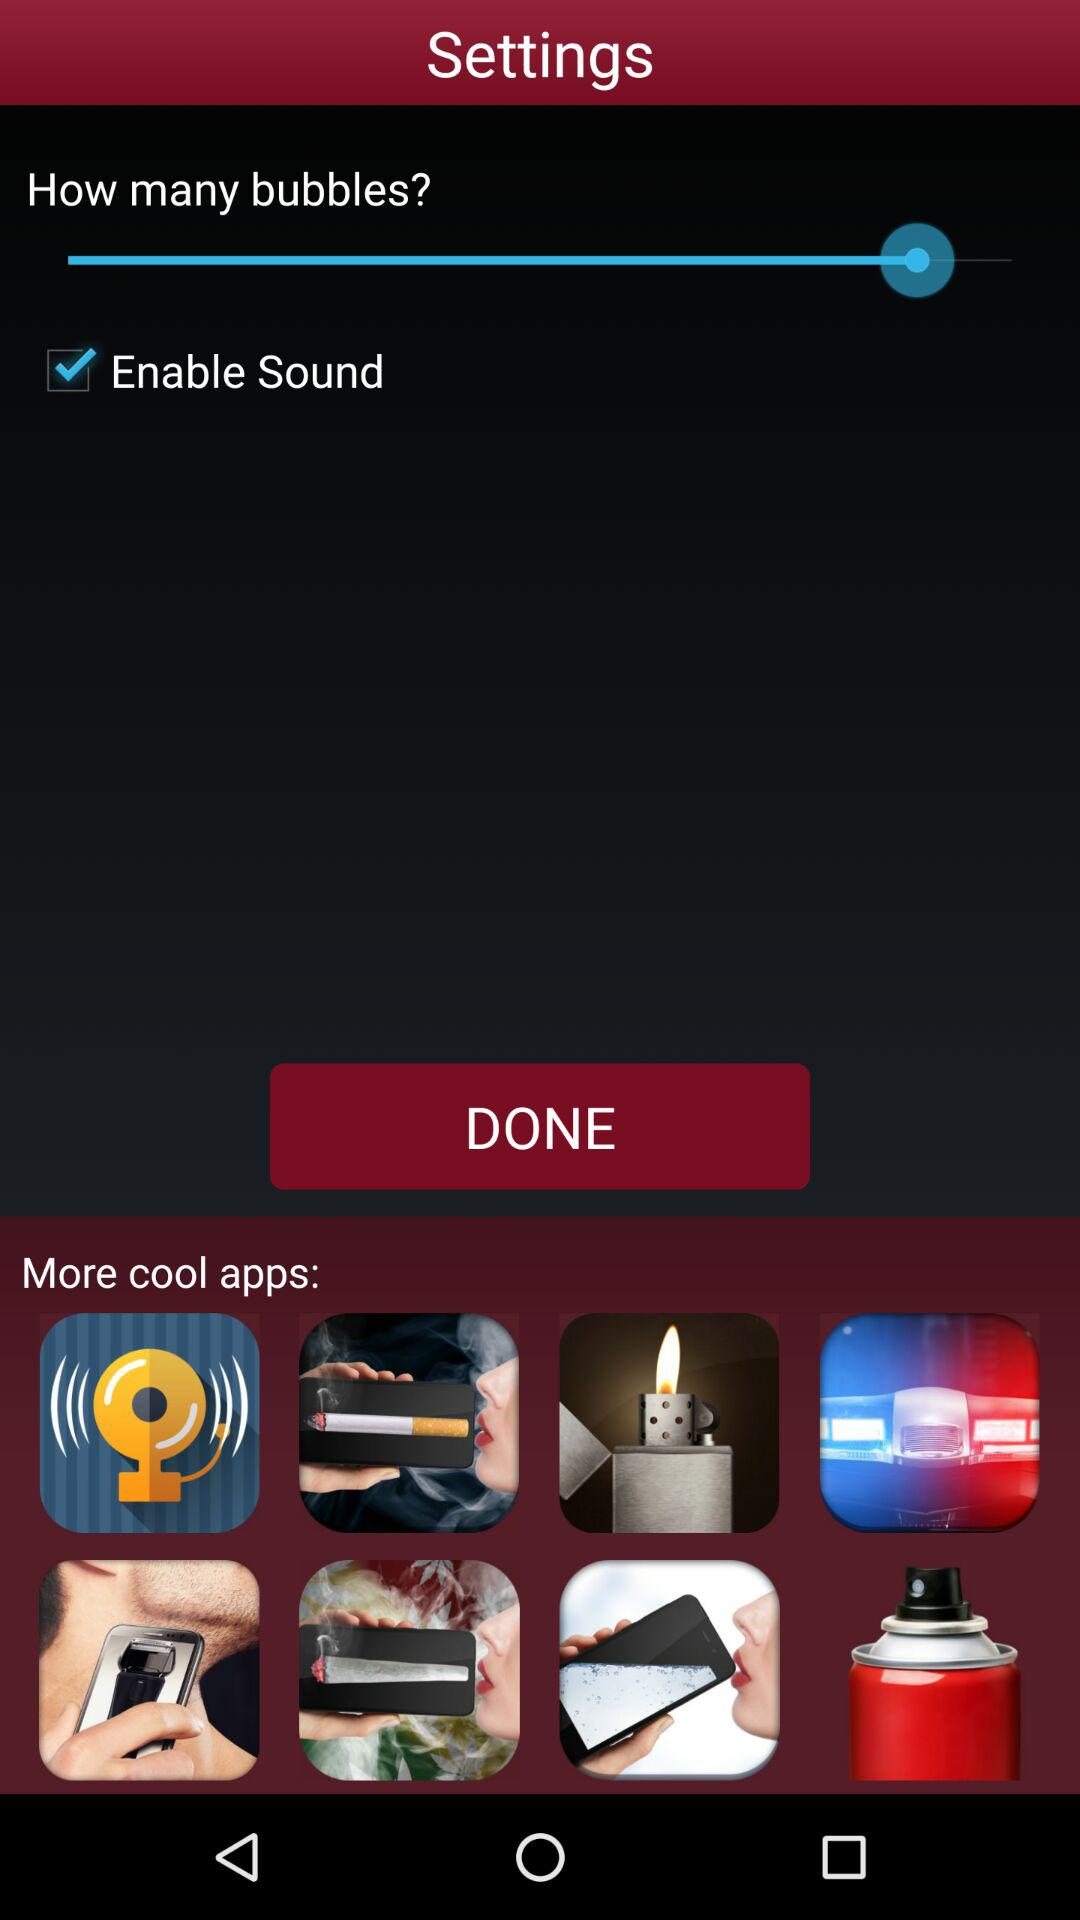What is the status of "Enable Sound"? The status is "on". 